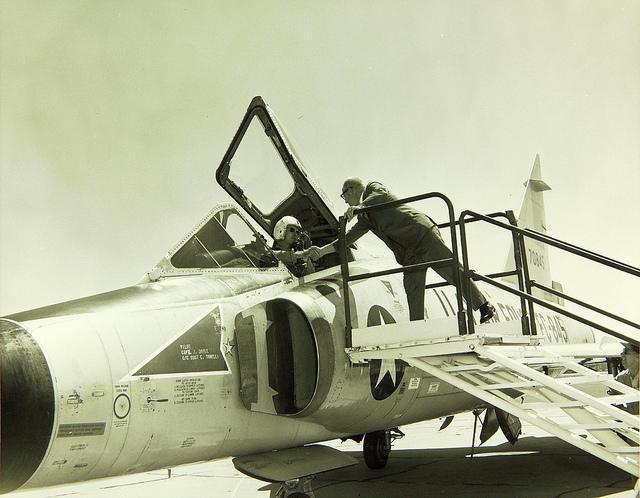How many stars are painted on the side of the plane?
Give a very brief answer. 1. 